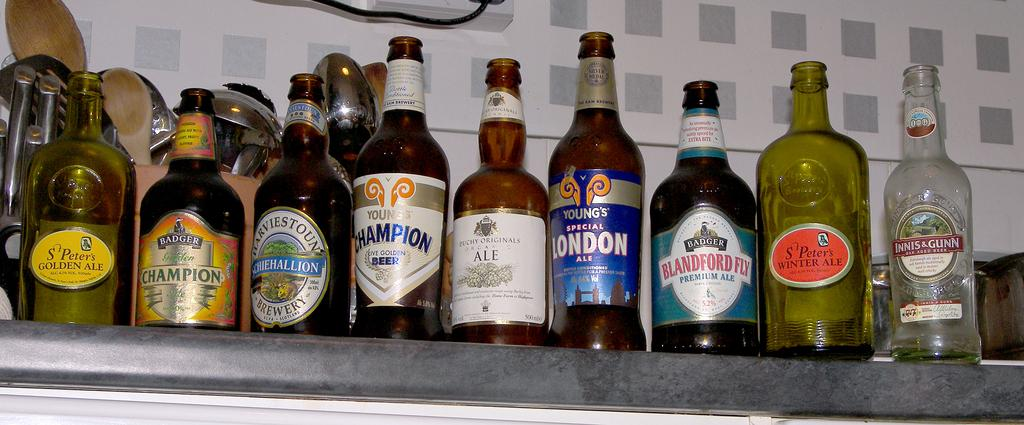<image>
Present a compact description of the photo's key features. a beer bottle with the word Blandford on the front 